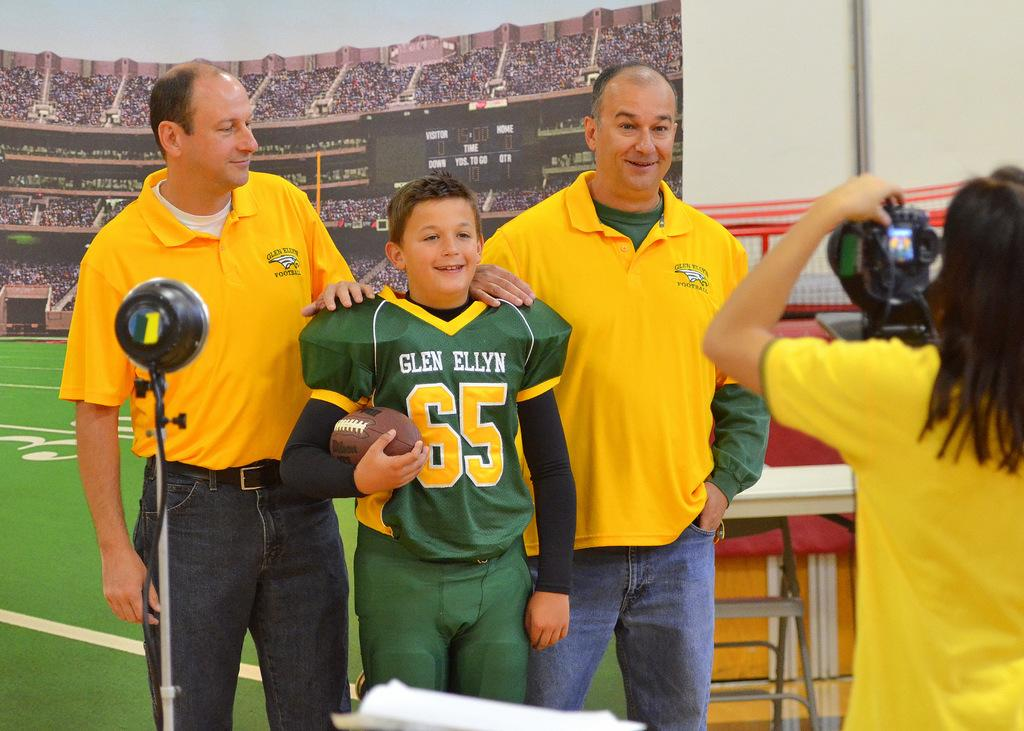<image>
Create a compact narrative representing the image presented. Number 65 for the Glen Ellyn football team poses with two men. 